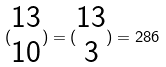Convert formula to latex. <formula><loc_0><loc_0><loc_500><loc_500>( \begin{matrix} 1 3 \\ 1 0 \end{matrix} ) = ( \begin{matrix} 1 3 \\ 3 \end{matrix} ) = 2 8 6</formula> 